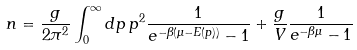Convert formula to latex. <formula><loc_0><loc_0><loc_500><loc_500>n = \frac { g } { 2 \pi ^ { 2 } } \int _ { 0 } ^ { \infty } d p \, p ^ { 2 } \frac { 1 } { e ^ { - \beta ( \mu - E ( p ) ) } - 1 } + \frac { g } { V } \frac { 1 } { e ^ { - \beta \mu } - 1 }</formula> 